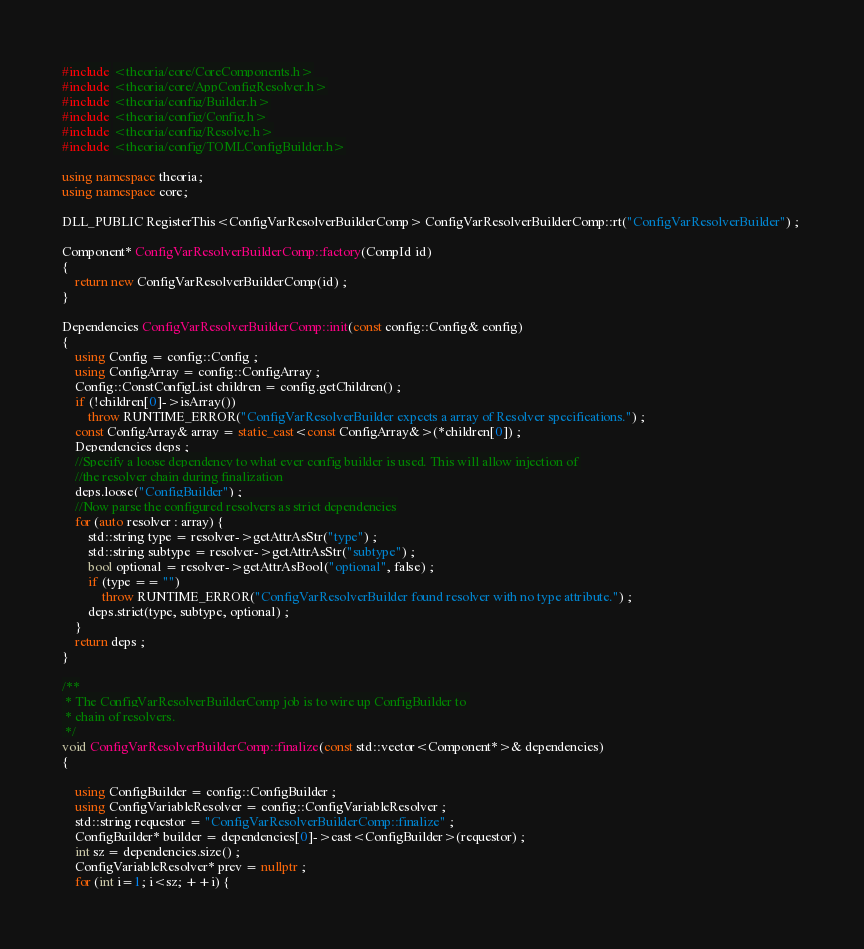Convert code to text. <code><loc_0><loc_0><loc_500><loc_500><_C++_>#include <theoria/core/CoreComponents.h>
#include <theoria/core/AppConfigResolver.h>
#include <theoria/config/Builder.h>
#include <theoria/config/Config.h>
#include <theoria/config/Resolve.h>
#include <theoria/config/TOMLConfigBuilder.h>

using namespace theoria;
using namespace core;

DLL_PUBLIC RegisterThis<ConfigVarResolverBuilderComp> ConfigVarResolverBuilderComp::rt("ConfigVarResolverBuilder") ; 

Component* ConfigVarResolverBuilderComp::factory(CompId id) 
{
    return new ConfigVarResolverBuilderComp(id) ;
}

Dependencies ConfigVarResolverBuilderComp::init(const config::Config& config) 
{
    using Config = config::Config ;
    using ConfigArray = config::ConfigArray ;
    Config::ConstConfigList children = config.getChildren() ;
    if (!children[0]->isArray())
        throw RUNTIME_ERROR("ConfigVarResolverBuilder expects a array of Resolver specifications.") ;
    const ConfigArray& array = static_cast<const ConfigArray&>(*children[0]) ;
    Dependencies deps ;
    //Specify a loose dependency to what ever config builder is used. This will allow injection of
    //the resolver chain during finalization
    deps.loose("ConfigBuilder") ;
    //Now parse the configured resolvers as strict dependencies
    for (auto resolver : array) {
        std::string type = resolver->getAttrAsStr("type") ; 
        std::string subtype = resolver->getAttrAsStr("subtype") ;
        bool optional = resolver->getAttrAsBool("optional", false) ;
        if (type == "") 
            throw RUNTIME_ERROR("ConfigVarResolverBuilder found resolver with no type attribute.") ;
        deps.strict(type, subtype, optional) ;
    }
    return deps ; 
}

/**
 * The ConfigVarResolverBuilderComp job is to wire up ConfigBuilder to 
 * chain of resolvers. 
 */
void ConfigVarResolverBuilderComp::finalize(const std::vector<Component*>& dependencies) 
{
    
    using ConfigBuilder = config::ConfigBuilder ;
    using ConfigVariableResolver = config::ConfigVariableResolver ;
    std::string requestor = "ConfigVarResolverBuilderComp::finalize" ;
    ConfigBuilder* builder = dependencies[0]->cast<ConfigBuilder>(requestor) ;
    int sz = dependencies.size() ;
    ConfigVariableResolver* prev = nullptr ;
    for (int i=1; i<sz; ++i) {</code> 